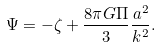<formula> <loc_0><loc_0><loc_500><loc_500>\Psi = - \zeta + \frac { 8 \pi G \Pi } { 3 } \frac { a ^ { 2 } } { k ^ { 2 } } .</formula> 